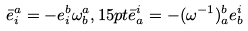Convert formula to latex. <formula><loc_0><loc_0><loc_500><loc_500>\bar { e } _ { i } ^ { a } = - e _ { i } ^ { b } \omega _ { b } ^ { a } , 1 5 p t \bar { e } _ { a } ^ { i } = - ( \omega ^ { - 1 } ) _ { a } ^ { b } e _ { b } ^ { i }</formula> 